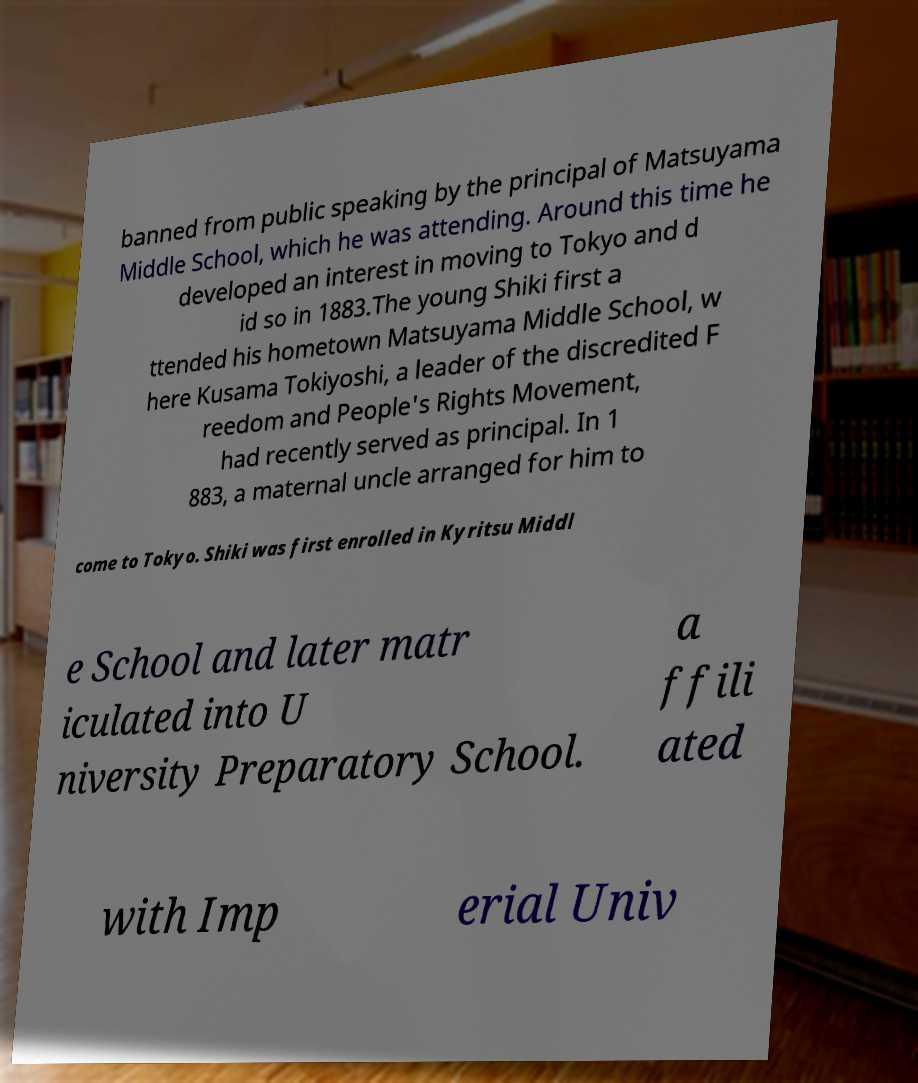For documentation purposes, I need the text within this image transcribed. Could you provide that? banned from public speaking by the principal of Matsuyama Middle School, which he was attending. Around this time he developed an interest in moving to Tokyo and d id so in 1883.The young Shiki first a ttended his hometown Matsuyama Middle School, w here Kusama Tokiyoshi, a leader of the discredited F reedom and People's Rights Movement, had recently served as principal. In 1 883, a maternal uncle arranged for him to come to Tokyo. Shiki was first enrolled in Kyritsu Middl e School and later matr iculated into U niversity Preparatory School. a ffili ated with Imp erial Univ 